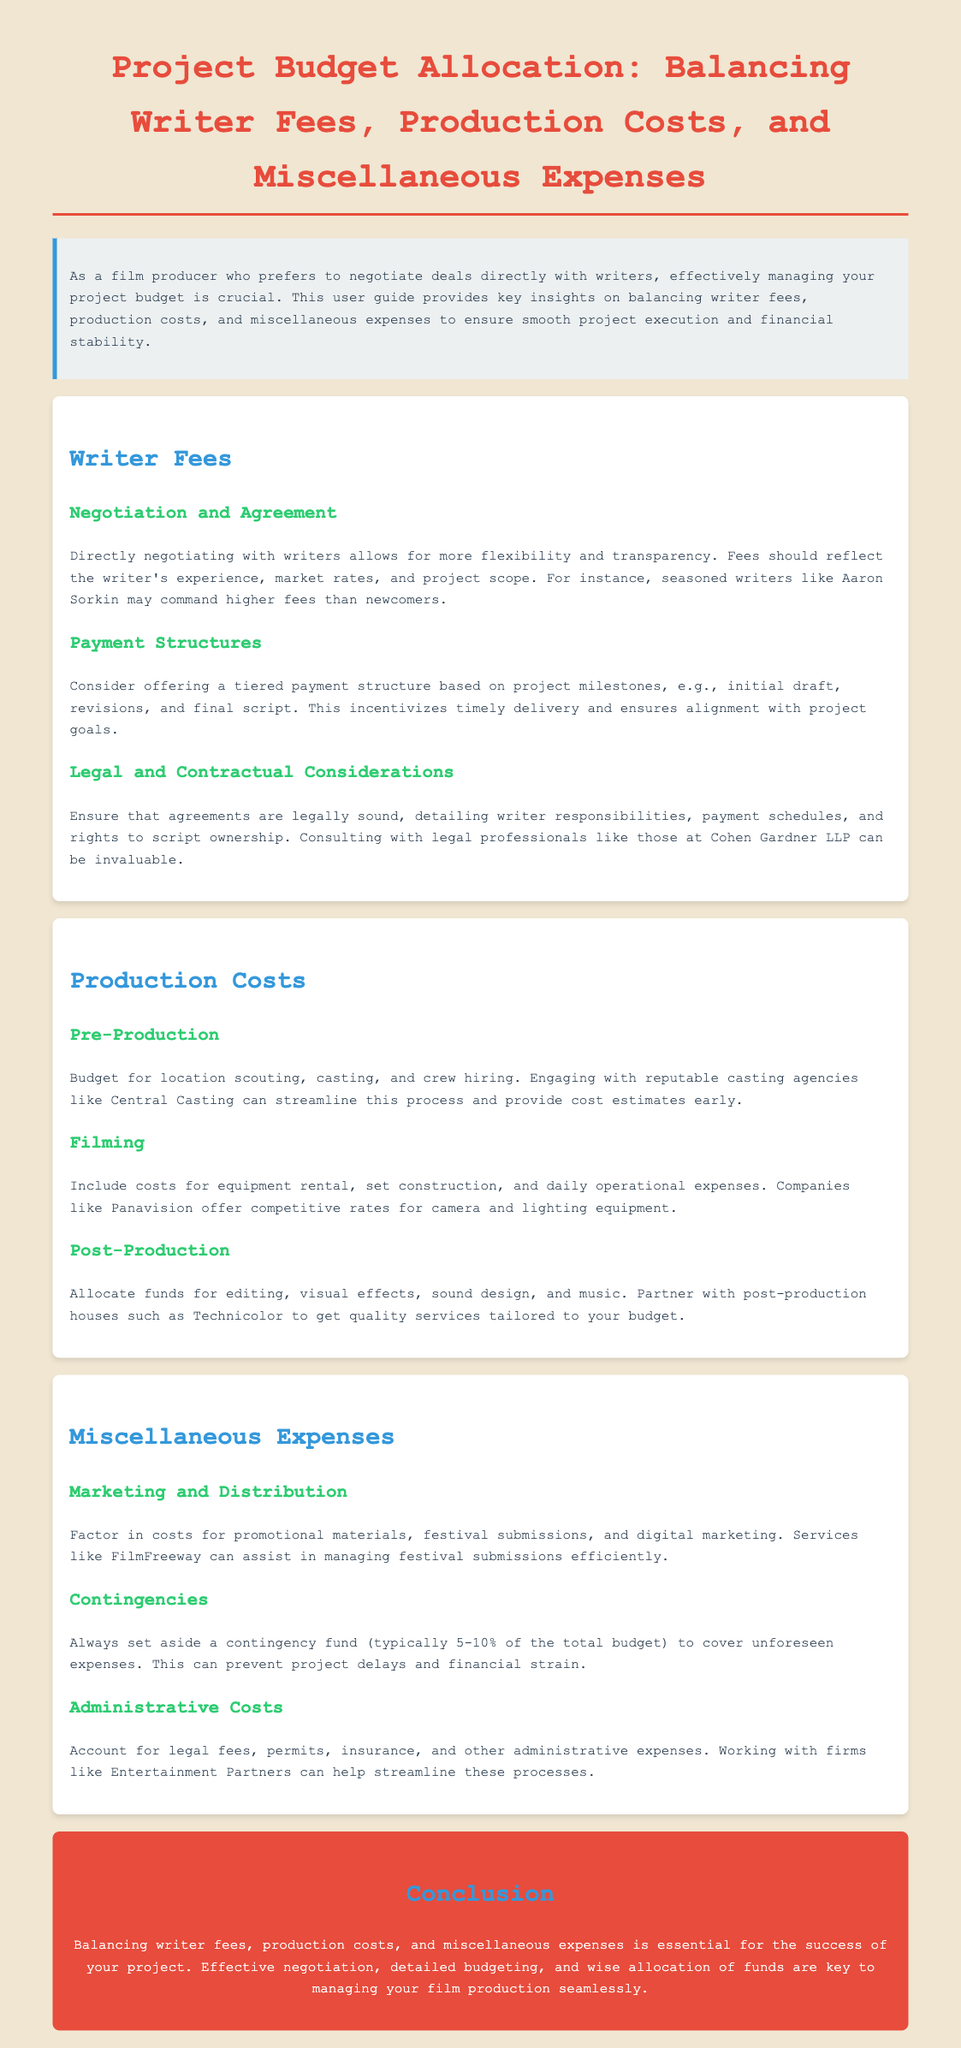What are the three main areas covered in the project budget allocation guide? The document lists three main areas: writer fees, production costs, and miscellaneous expenses.
Answer: writer fees, production costs, miscellaneous expenses Who provides valuable legal consultation for agreements? The document mentions consulting with legal professionals at Cohen Gardner LLP for invaluable assistance.
Answer: Cohen Gardner LLP What percentage of the total budget is recommended to set aside for contingencies? The guide suggests setting aside a contingency fund typically amounting to 5-10% of the total budget.
Answer: 5-10% What payment structure incentivizes timely delivery of scripts? A tiered payment structure based on project milestones, such as initial draft, revisions, and final script, incentivizes timely delivery.
Answer: tiered payment structure Which company is mentioned as offering competitive rates for equipment rental? The document refers to Panavision as a company that offers competitive rates for camera and lighting equipment rental.
Answer: Panavision What type of expenses should be included in miscellaneous expenses? The guide includes marketing and distribution, contingencies, and administrative costs as part of miscellaneous expenses.
Answer: marketing and distribution, contingencies, administrative costs What is the primary benefit of negotiating directly with writers? The document emphasizes that direct negotiation allows for more flexibility and transparency in deals.
Answer: flexibility and transparency Which service can assist in managing festival submissions? The guide mentions FilmFreeway as a service that can help manage festival submissions efficiently.
Answer: FilmFreeway 